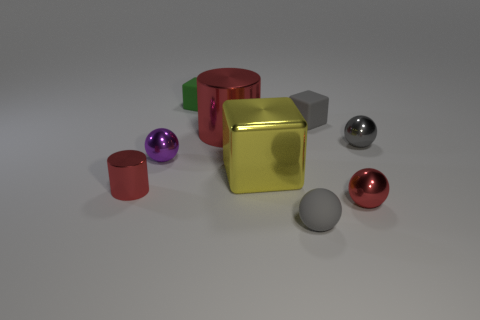Is the color of the matte thing on the left side of the big shiny cube the same as the matte block that is to the right of the tiny green cube?
Give a very brief answer. No. Are there an equal number of gray objects that are left of the small gray block and tiny purple things?
Ensure brevity in your answer.  Yes. There is a red ball; how many cylinders are behind it?
Provide a short and direct response. 2. The yellow cube is what size?
Your response must be concise. Large. There is a cube that is made of the same material as the green thing; what is its color?
Provide a short and direct response. Gray. How many metal cubes are the same size as the rubber ball?
Provide a short and direct response. 0. Is the material of the small gray thing that is to the right of the red shiny ball the same as the gray block?
Ensure brevity in your answer.  No. Are there fewer things in front of the big red metallic cylinder than purple metal spheres?
Provide a short and direct response. No. There is a red metallic thing to the right of the rubber sphere; what shape is it?
Offer a terse response. Sphere. There is a gray shiny object that is the same size as the purple metallic object; what shape is it?
Your answer should be compact. Sphere. 